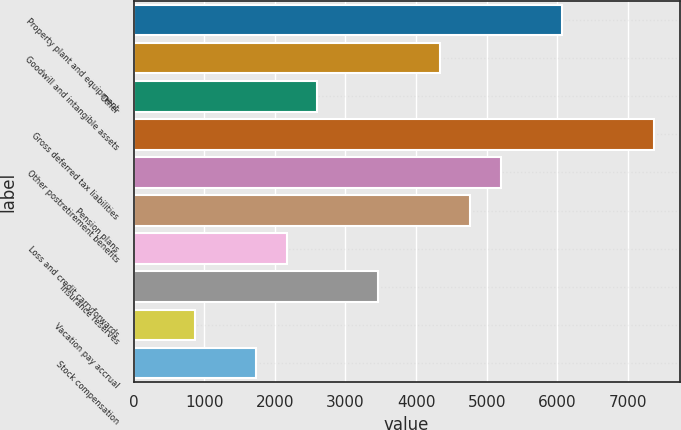<chart> <loc_0><loc_0><loc_500><loc_500><bar_chart><fcel>Property plant and equipment<fcel>Goodwill and intangible assets<fcel>Other<fcel>Gross deferred tax liabilities<fcel>Other postretirement benefits<fcel>Pension plans<fcel>Loss and credit carryforwards<fcel>Insurance reserves<fcel>Vacation pay accrual<fcel>Stock compensation<nl><fcel>6065.4<fcel>4333<fcel>2600.6<fcel>7364.7<fcel>5199.2<fcel>4766.1<fcel>2167.5<fcel>3466.8<fcel>868.2<fcel>1734.4<nl></chart> 